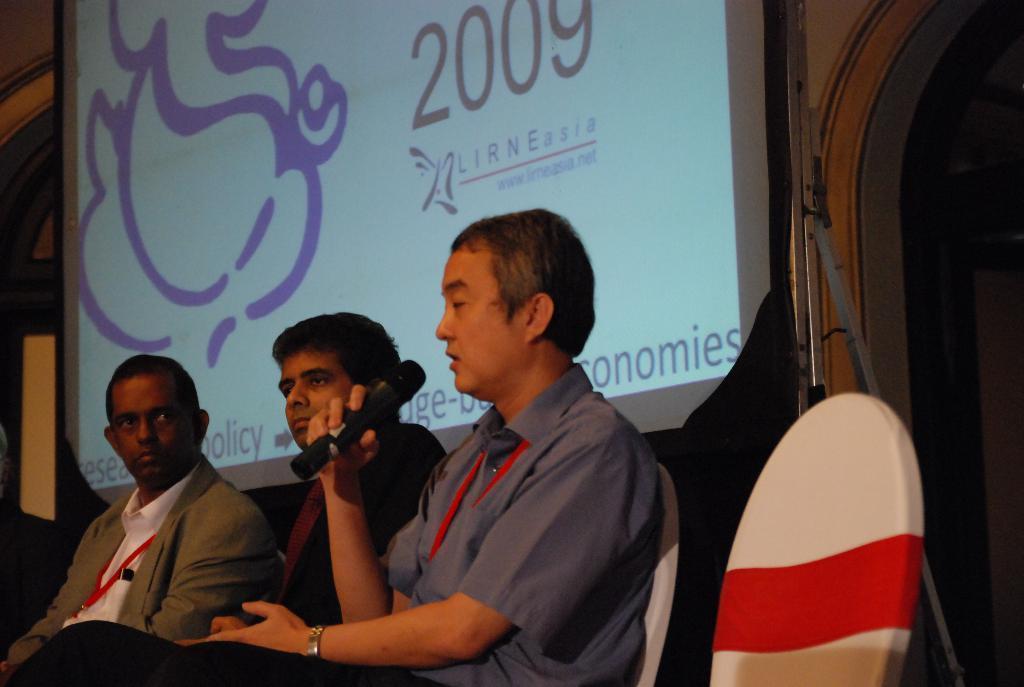Could you give a brief overview of what you see in this image? This picture might be taken in the conference hall. In this image, in the middle and on the left side, we can see three people sitting on the chair. In the middle, we can see a man sitting on the chair and holding a microphone in his hand. On the right side, we can see a chair. In the background, we can see a screen and a black color cloth. 